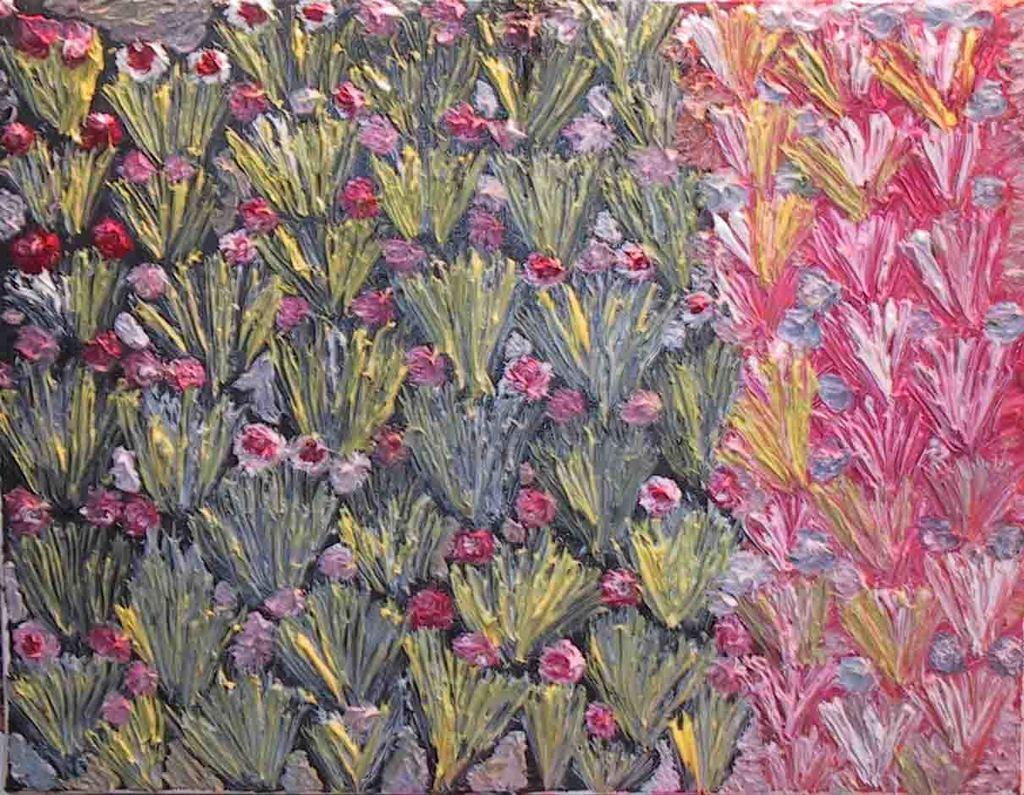Can you describe this image briefly? This painting consists of flowers painted in pink and white color with green leaves. 